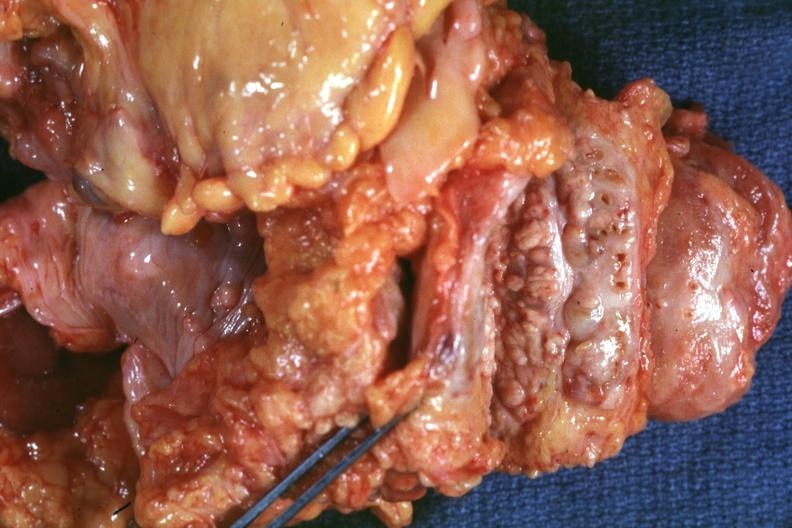what does this image show?
Answer the question using a single word or phrase. Bread-loaf slices into prostate gland photographed close-up showing nodular parenchyma and dense intervening tumor tissue very good 